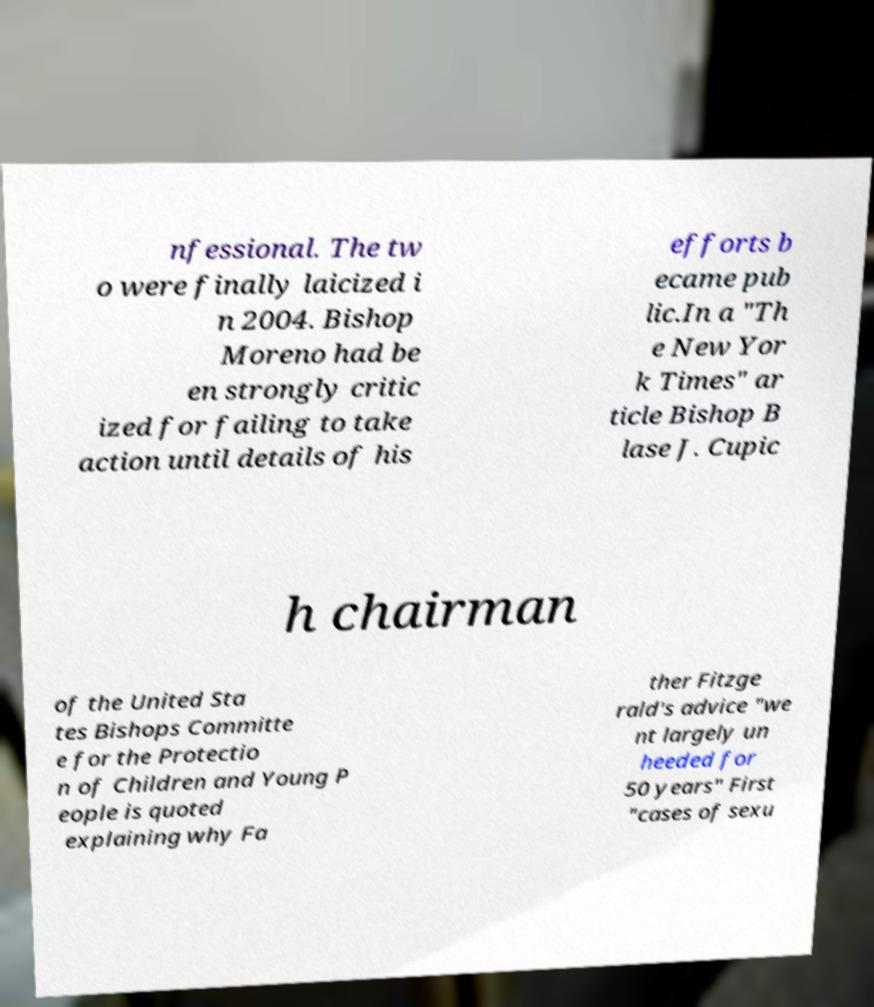I need the written content from this picture converted into text. Can you do that? nfessional. The tw o were finally laicized i n 2004. Bishop Moreno had be en strongly critic ized for failing to take action until details of his efforts b ecame pub lic.In a "Th e New Yor k Times" ar ticle Bishop B lase J. Cupic h chairman of the United Sta tes Bishops Committe e for the Protectio n of Children and Young P eople is quoted explaining why Fa ther Fitzge rald's advice "we nt largely un heeded for 50 years" First "cases of sexu 